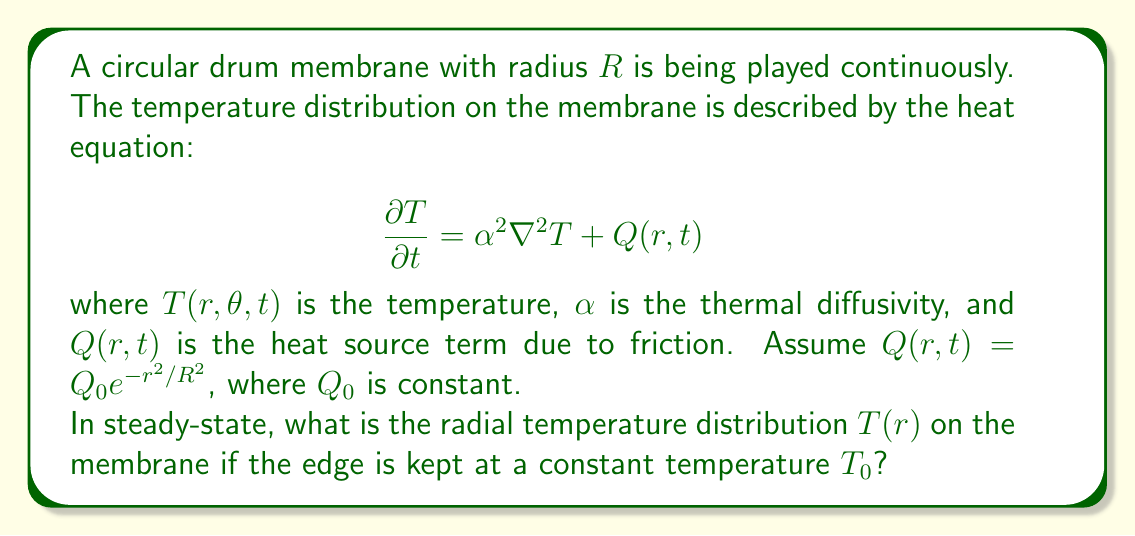Can you solve this math problem? To solve this problem, we'll follow these steps:

1) In steady-state, the time derivative becomes zero: $\frac{\partial T}{\partial t} = 0$

2) The Laplacian in polar coordinates (assuming radial symmetry) is:

   $$\nabla^2 T = \frac{1}{r}\frac{\partial}{\partial r}\left(r\frac{\partial T}{\partial r}\right)$$

3) Our steady-state heat equation becomes:

   $$0 = \alpha^2 \frac{1}{r}\frac{d}{dr}\left(r\frac{dT}{dr}\right) + Q_0 e^{-r^2/R^2}$$

4) Multiply both sides by $r$:

   $$0 = \alpha^2 \frac{d}{dr}\left(r\frac{dT}{dr}\right) + Q_0 r e^{-r^2/R^2}$$

5) Integrate both sides with respect to $r$:

   $$C_1 = \alpha^2 r\frac{dT}{dr} - Q_0 \frac{R^2}{2}e^{-r^2/R^2}$$

   where $C_1$ is a constant of integration.

6) Divide by $r$ and integrate again:

   $$T(r) = -\frac{Q_0 R^2}{4\alpha^2} E_1\left(\frac{r^2}{R^2}\right) + C_2 + C_1 \ln(r)$$

   where $E_1$ is the exponential integral and $C_2$ is another constant.

7) Apply the boundary condition $T(R) = T_0$ and the condition that $T$ must be finite at $r=0$ (which implies $C_1 = 0$):

   $$T_0 = -\frac{Q_0 R^2}{4\alpha^2} E_1(1) + C_2$$

8) Solve for $C_2$ and substitute back:

   $$T(r) = T_0 + \frac{Q_0 R^2}{4\alpha^2} \left[E_1(1) - E_1\left(\frac{r^2}{R^2}\right)\right]$$

This is the radial temperature distribution on the drum membrane.
Answer: $T(r) = T_0 + \frac{Q_0 R^2}{4\alpha^2} \left[E_1(1) - E_1\left(\frac{r^2}{R^2}\right)\right]$ 